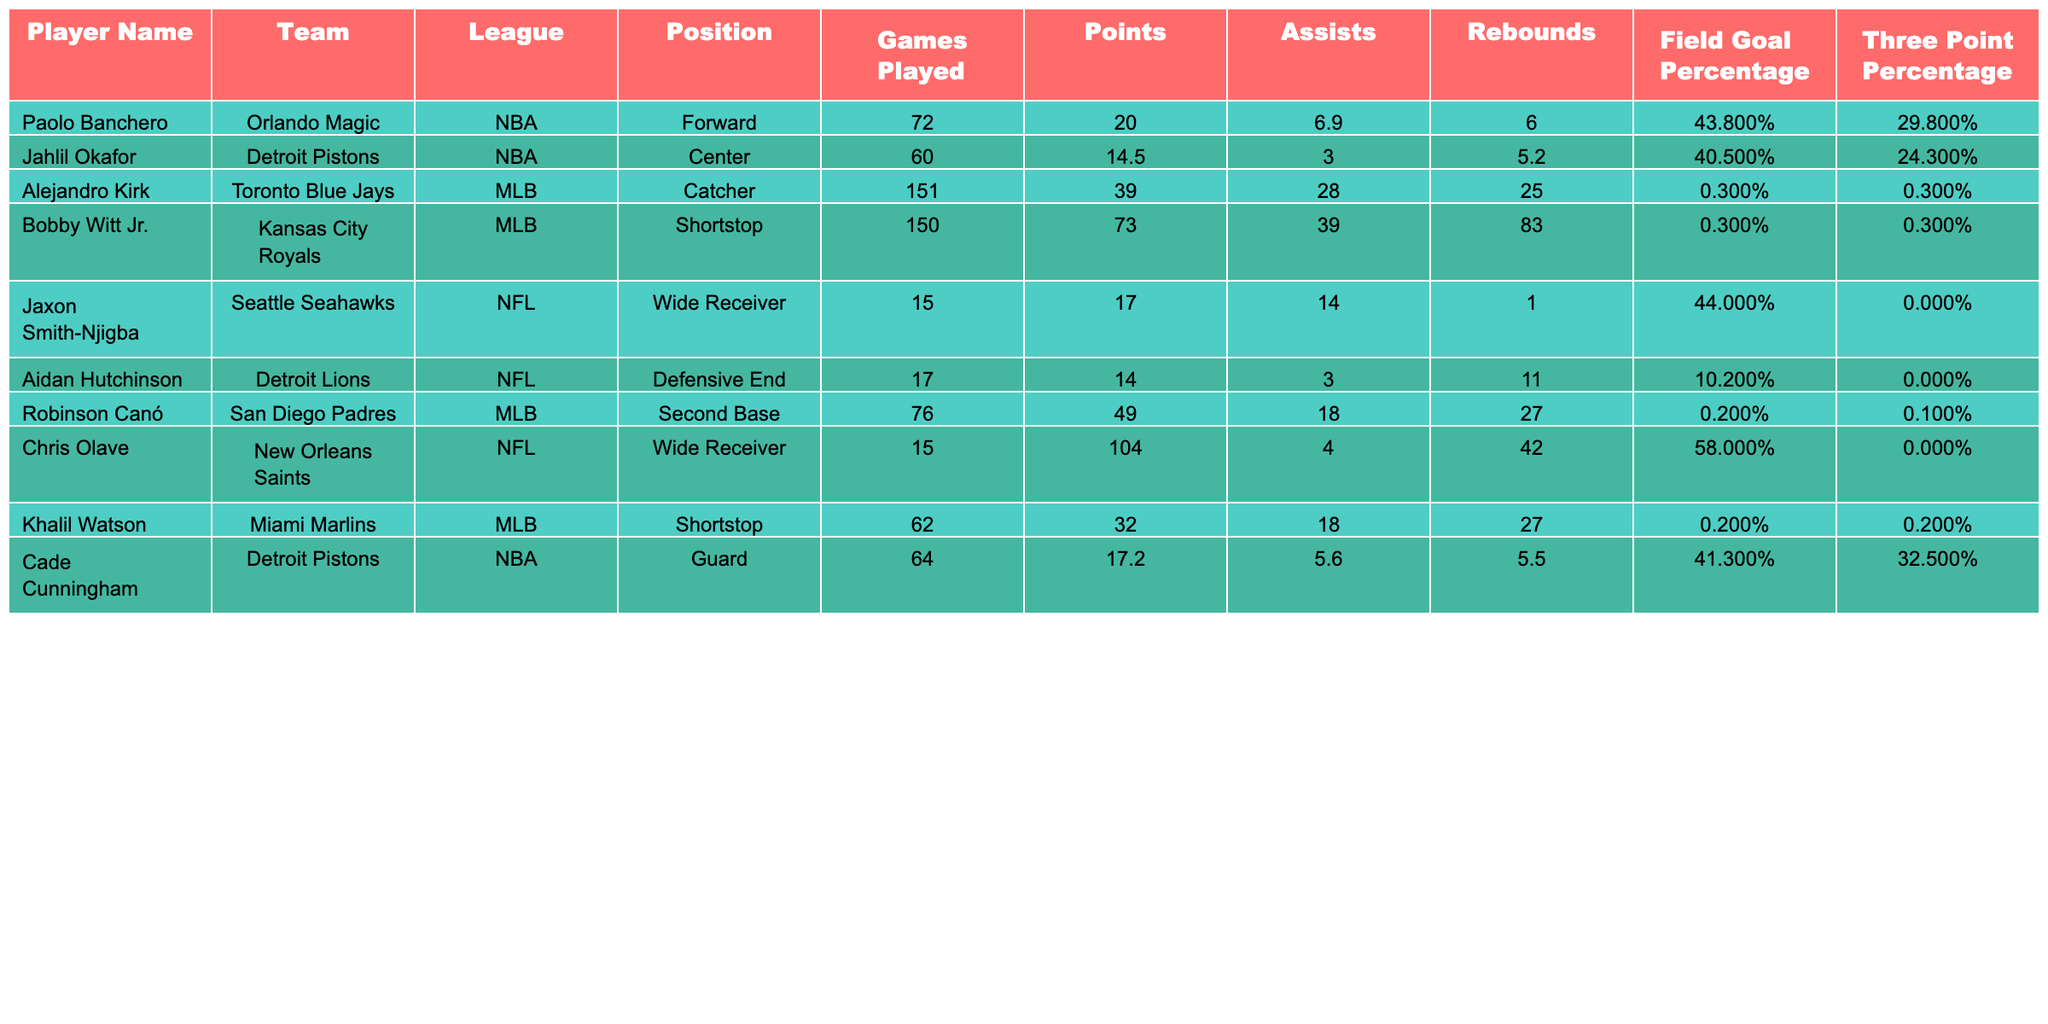What is the highest points scored by a rookie athlete in this table? By examining the "Points" column, we can see that Chris Olave scored the highest with 104 points.
Answer: 104 Who has the lowest field goal percentage among the players listed? By looking at the "Field Goal Percentage" column, Aidan Hutchinson has the lowest at 10.2%.
Answer: 10.2% What is the average points scored by the NBA players in this table? The NBA players listed are Paolo Banchero, Jahlil Okafor, and Cade Cunningham. Their points are 20.0, 14.5, and 17.2, respectively. So, the average is (20.0 + 14.5 + 17.2) / 3 = 17.23.
Answer: 17.23 Did any player achieve a zero percentage in three-point shooting? By checking the "Three Point Percentage" column, Jaxon Smith-Njigba and Aidan Hutchinson both have a three-point percentage of 0.0%.
Answer: Yes Which player played the most games in the MLB, and what were their performance statistics? Alejandro Kirk played the most games (151) and scored 39 points, made 28 assists, and had a field goal percentage of 28.6%.
Answer: Alejandro Kirk; 39 points, 28 assists, 28.6% FG How do the assist averages of MLB players compare with those of NBA players? The MLB players Alejandro Kirk, Bobby Witt Jr., and Robinson Canó averaged (28 + 39 + 18) / 3 = 28.33 assists, while NBA players Paolo Banchero, Jahlil Okafor, and Cade Cunningham averaged (6.9 + 3.0 + 5.6) / 3 = 5.17 assists. MLB players have a higher average.
Answer: MLB players have a higher average What position did the player with the most rebounds play? By checking the "Rebounds" column and their corresponding positions, Bobby Witt Jr. had the most rebounds with 83 and plays the position of Shortstop.
Answer: Shortstop Is there any NFL rookie that scored more points than the NBA rookies listed? Chris Olave scored 104 points in the NFL, which is higher than Paolo Banchero's 20.0 points, Jahlil Okafor's 14.5 points, and Cade Cunningham's 17.2 points.
Answer: Yes, Chris Olave What is the percentage difference between the highest and lowest field goal percentages of the rookies? The highest is Chris Olave at 58.0% and the lowest is Aidan Hutchinson at 10.2%. The percentage difference is 58.0 - 10.2 = 47.8%.
Answer: 47.8% 